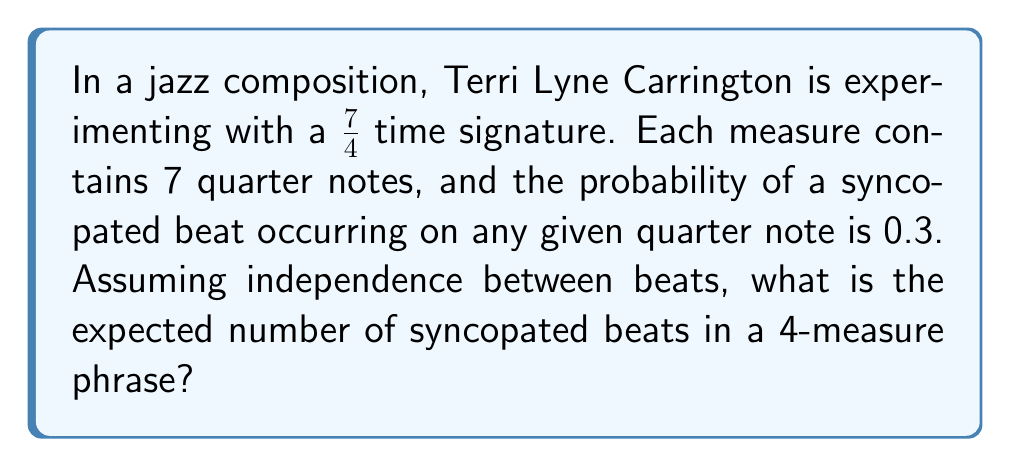Could you help me with this problem? Let's approach this step-by-step:

1) First, we need to determine the total number of quarter notes in a 4-measure phrase:
   - Each measure has 7 quarter notes
   - There are 4 measures
   - Total quarter notes = $7 * 4 = 28$

2) For each quarter note, we have a binomial probability distribution:
   - Success (syncopated beat) probability = 0.3
   - Failure (regular beat) probability = 0.7

3) The expected number of successes in a binomial distribution is given by the formula:
   $$ E(X) = np $$
   Where:
   - $n$ is the number of trials (in this case, total quarter notes)
   - $p$ is the probability of success on each trial

4) Substituting our values:
   $$ E(X) = 28 * 0.3 = 8.4 $$

Therefore, the expected number of syncopated beats in a 4-measure phrase is 8.4.
Answer: 8.4 syncopated beats 